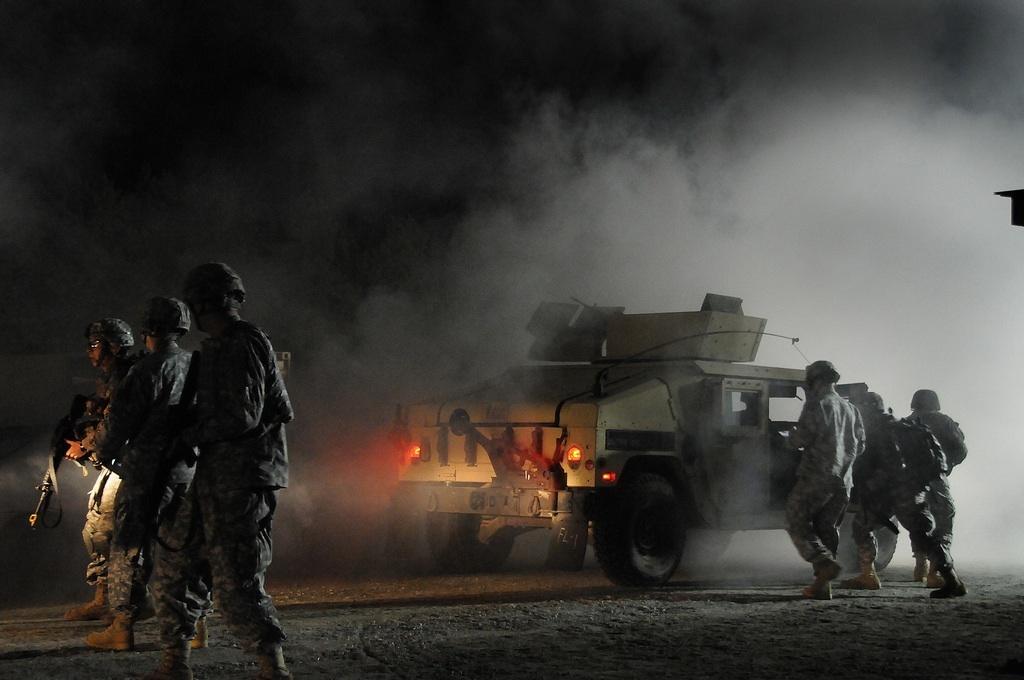Please provide a concise description of this image. This picture describes about group of people, few people wore helmets, in the background we can see a vehicle and smoke. 